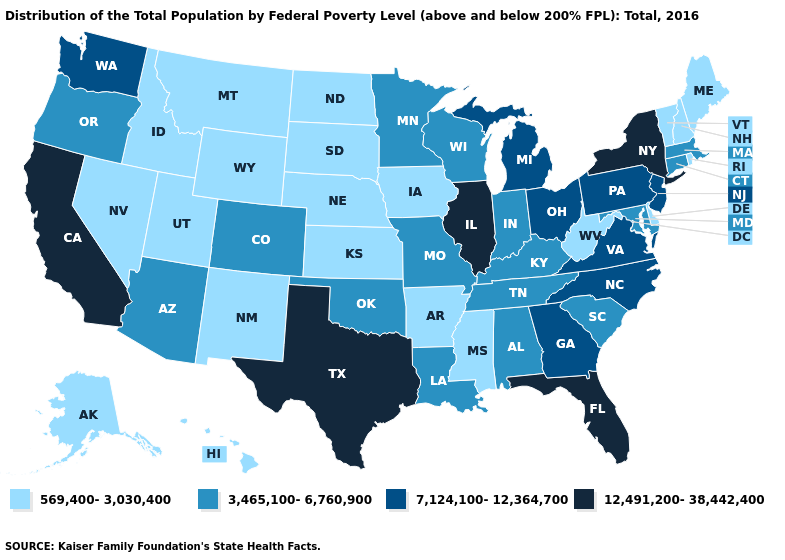What is the value of Alabama?
Keep it brief. 3,465,100-6,760,900. Does the first symbol in the legend represent the smallest category?
Concise answer only. Yes. Does the first symbol in the legend represent the smallest category?
Short answer required. Yes. Name the states that have a value in the range 12,491,200-38,442,400?
Concise answer only. California, Florida, Illinois, New York, Texas. Name the states that have a value in the range 7,124,100-12,364,700?
Concise answer only. Georgia, Michigan, New Jersey, North Carolina, Ohio, Pennsylvania, Virginia, Washington. Name the states that have a value in the range 7,124,100-12,364,700?
Short answer required. Georgia, Michigan, New Jersey, North Carolina, Ohio, Pennsylvania, Virginia, Washington. What is the highest value in the USA?
Concise answer only. 12,491,200-38,442,400. Name the states that have a value in the range 3,465,100-6,760,900?
Short answer required. Alabama, Arizona, Colorado, Connecticut, Indiana, Kentucky, Louisiana, Maryland, Massachusetts, Minnesota, Missouri, Oklahoma, Oregon, South Carolina, Tennessee, Wisconsin. Does Arizona have a higher value than Louisiana?
Keep it brief. No. Name the states that have a value in the range 3,465,100-6,760,900?
Concise answer only. Alabama, Arizona, Colorado, Connecticut, Indiana, Kentucky, Louisiana, Maryland, Massachusetts, Minnesota, Missouri, Oklahoma, Oregon, South Carolina, Tennessee, Wisconsin. What is the value of Pennsylvania?
Give a very brief answer. 7,124,100-12,364,700. Name the states that have a value in the range 7,124,100-12,364,700?
Be succinct. Georgia, Michigan, New Jersey, North Carolina, Ohio, Pennsylvania, Virginia, Washington. What is the value of Indiana?
Short answer required. 3,465,100-6,760,900. Which states have the lowest value in the Northeast?
Concise answer only. Maine, New Hampshire, Rhode Island, Vermont. Among the states that border Virginia , which have the lowest value?
Give a very brief answer. West Virginia. 